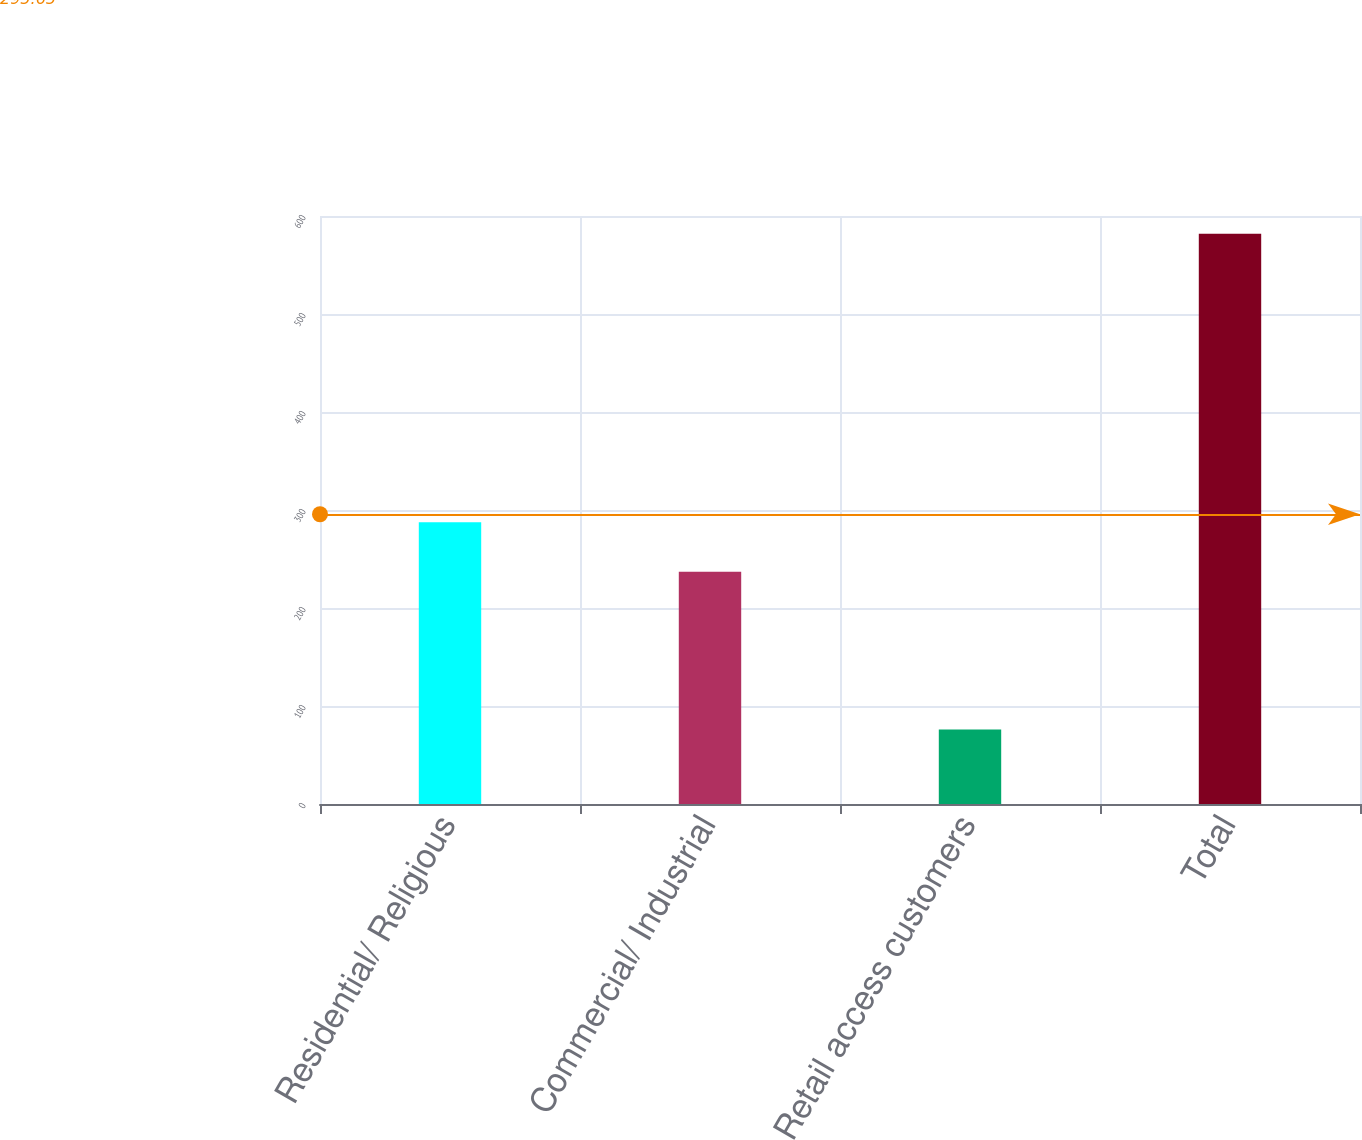Convert chart. <chart><loc_0><loc_0><loc_500><loc_500><bar_chart><fcel>Residential/ Religious<fcel>Commercial/ Industrial<fcel>Retail access customers<fcel>Total<nl><fcel>287.6<fcel>237<fcel>76<fcel>582<nl></chart> 